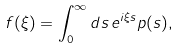<formula> <loc_0><loc_0><loc_500><loc_500>f ( \xi ) = \int _ { 0 } ^ { \infty } d s \, e ^ { i \xi s } p ( s ) ,</formula> 